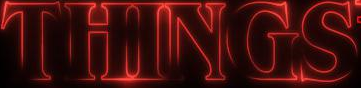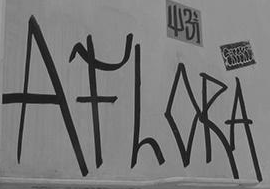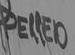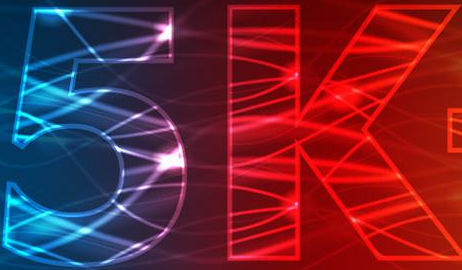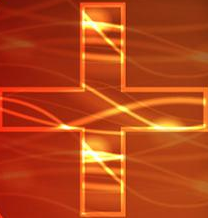Transcribe the words shown in these images in order, separated by a semicolon. THINGS; AFLORA; PELLED; 5k; + 